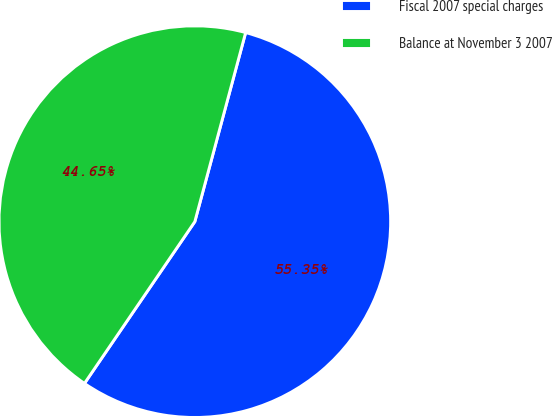<chart> <loc_0><loc_0><loc_500><loc_500><pie_chart><fcel>Fiscal 2007 special charges<fcel>Balance at November 3 2007<nl><fcel>55.35%<fcel>44.65%<nl></chart> 